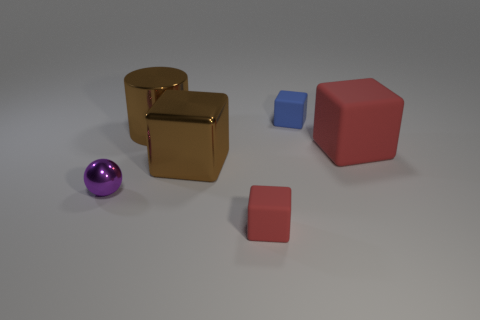What material is the tiny object that is to the right of the large brown metallic cube and to the left of the tiny blue rubber thing?
Your response must be concise. Rubber. There is a tiny thing behind the large red thing; is there a tiny purple metallic thing that is in front of it?
Offer a terse response. Yes. Are the tiny purple thing and the cylinder made of the same material?
Provide a short and direct response. Yes. The metallic thing that is both in front of the brown cylinder and on the right side of the small purple metallic ball has what shape?
Offer a terse response. Cube. What size is the blue matte object behind the tiny matte thing that is in front of the brown shiny cylinder?
Ensure brevity in your answer.  Small. What number of other rubber things are the same shape as the tiny blue thing?
Make the answer very short. 2. Do the large cylinder and the big shiny block have the same color?
Give a very brief answer. Yes. Is there any other thing that is the same shape as the purple metal thing?
Offer a terse response. No. Are there any balls of the same color as the cylinder?
Ensure brevity in your answer.  No. Is the red block in front of the large red matte thing made of the same material as the sphere to the left of the brown cube?
Ensure brevity in your answer.  No. 